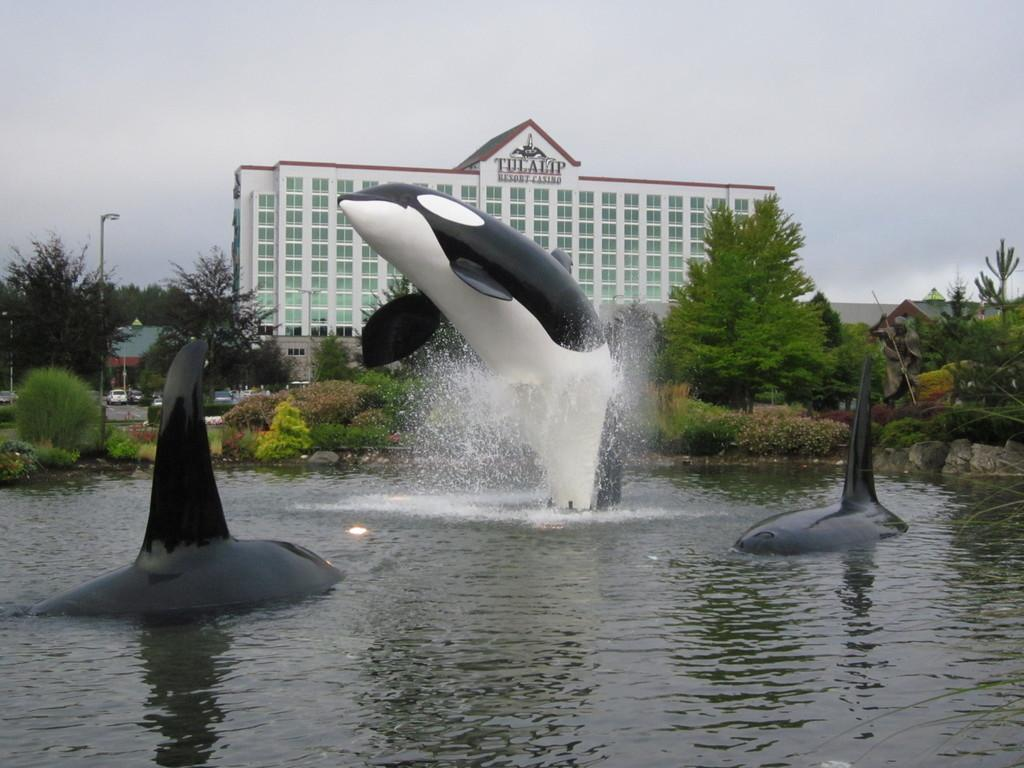What type of animals can be seen in the water in the image? There are dolphin fishes in the water in the image. What type of vegetation is visible in the image? There are plants and trees visible in the image. What type of structure can be seen in the image? There is a building in the image. What is visible at the top of the image? The sky is visible at the top of the image. What type of birthday celebration is taking place in the image? There is no indication of a birthday celebration in the image. What desires are being expressed by the dolphin fishes in the image? Dolphin fishes do not have the ability to express desires, and there is no indication of any desires being expressed in the image. 